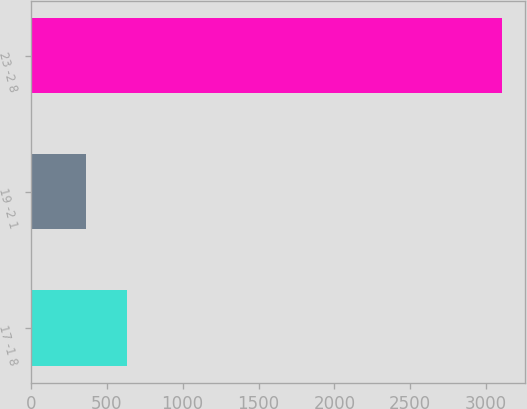Convert chart to OTSL. <chart><loc_0><loc_0><loc_500><loc_500><bar_chart><fcel>17 -1 8<fcel>19 -2 1<fcel>23 -2 8<nl><fcel>636.1<fcel>362<fcel>3103<nl></chart> 